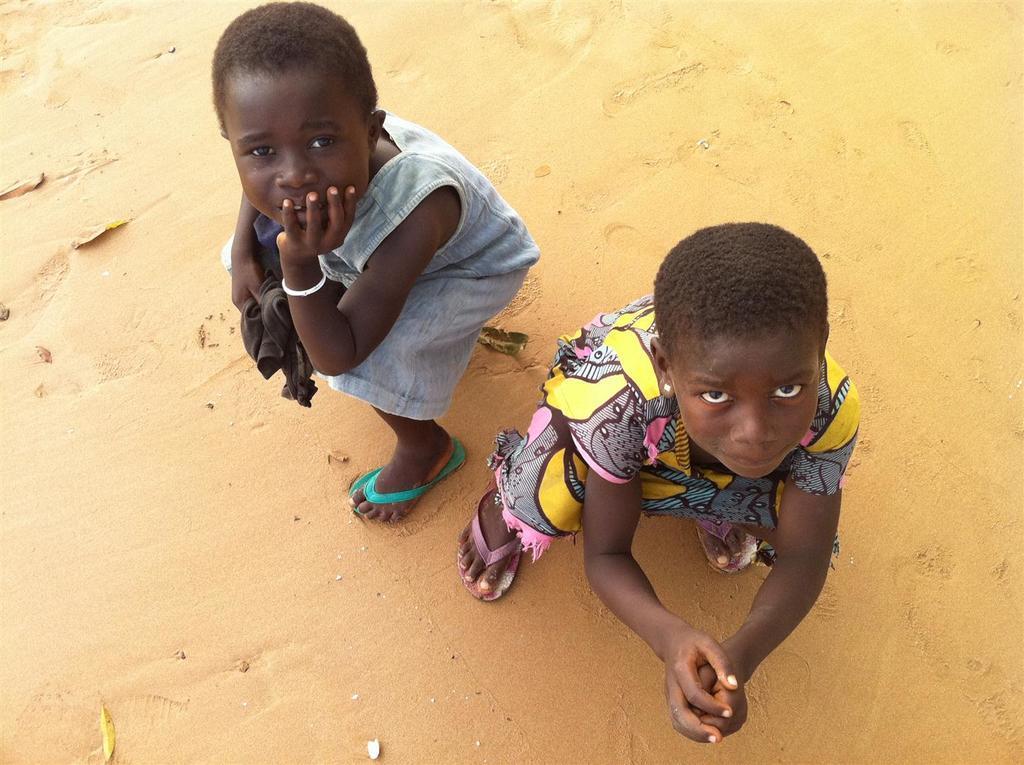In one or two sentences, can you explain what this image depicts? In this image there are two kids on the land. Left side there is a kid holding a cloth. 